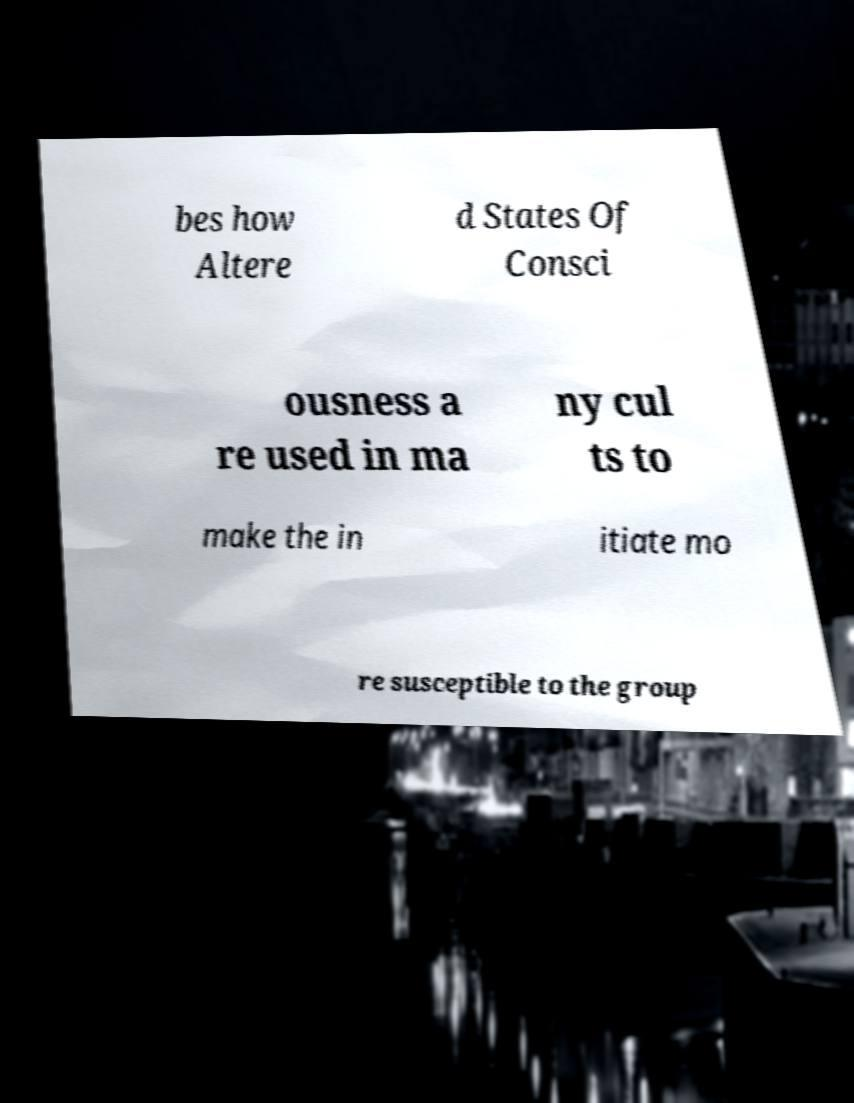What messages or text are displayed in this image? I need them in a readable, typed format. bes how Altere d States Of Consci ousness a re used in ma ny cul ts to make the in itiate mo re susceptible to the group 